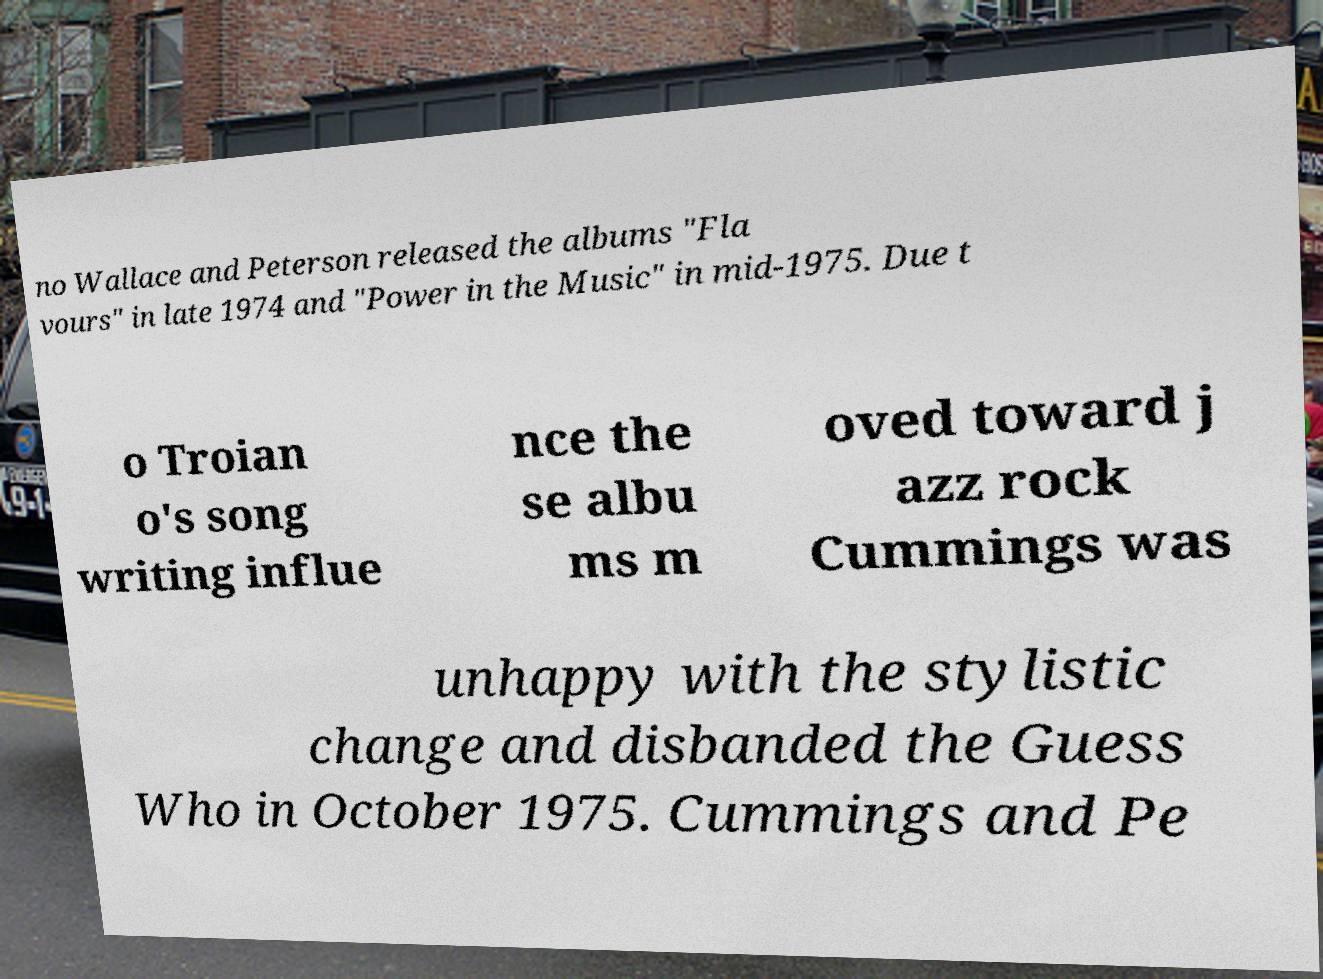Please read and relay the text visible in this image. What does it say? no Wallace and Peterson released the albums "Fla vours" in late 1974 and "Power in the Music" in mid-1975. Due t o Troian o's song writing influe nce the se albu ms m oved toward j azz rock Cummings was unhappy with the stylistic change and disbanded the Guess Who in October 1975. Cummings and Pe 